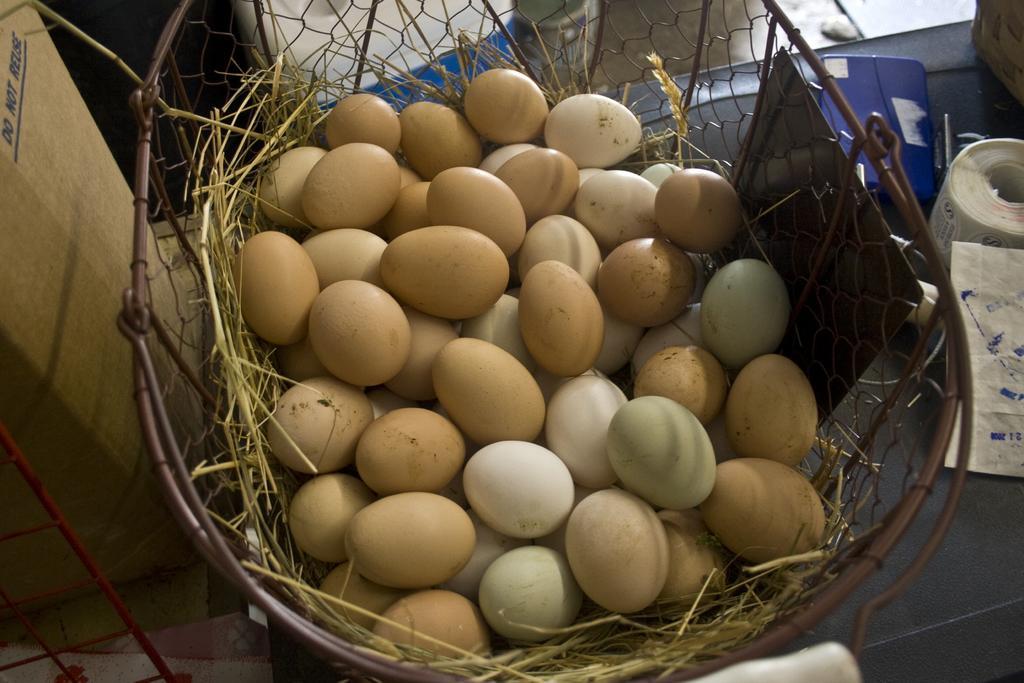Describe this image in one or two sentences. In this image I can see the eggs in the basket. To the left I can see the cardboard box. To the right I can see the tissue role and some objects. These are on the grey color surface. 